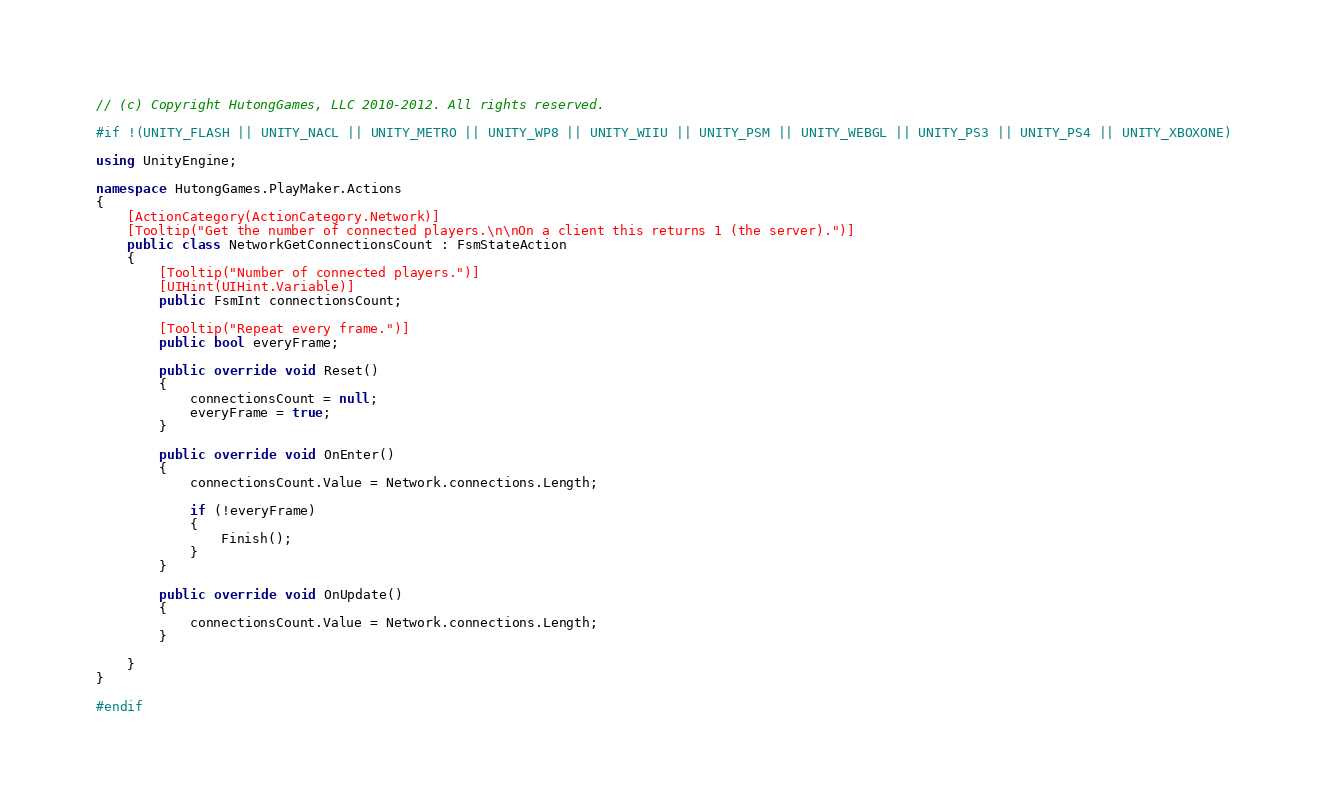<code> <loc_0><loc_0><loc_500><loc_500><_C#_>// (c) Copyright HutongGames, LLC 2010-2012. All rights reserved.

#if !(UNITY_FLASH || UNITY_NACL || UNITY_METRO || UNITY_WP8 || UNITY_WIIU || UNITY_PSM || UNITY_WEBGL || UNITY_PS3 || UNITY_PS4 || UNITY_XBOXONE)

using UnityEngine;

namespace HutongGames.PlayMaker.Actions
{
	[ActionCategory(ActionCategory.Network)]
	[Tooltip("Get the number of connected players.\n\nOn a client this returns 1 (the server).")]
	public class NetworkGetConnectionsCount : FsmStateAction
	{
		[Tooltip("Number of connected players.")]
		[UIHint(UIHint.Variable)]
		public FsmInt connectionsCount;
		
		[Tooltip("Repeat every frame.")]
		public bool everyFrame;

		public override void Reset()
		{
			connectionsCount = null;
			everyFrame = true;
		}

		public override void OnEnter()
		{
			connectionsCount.Value = Network.connections.Length;
			
			if (!everyFrame)
			{
				Finish();
			}
		}

		public override void OnUpdate()
		{
			connectionsCount.Value = Network.connections.Length;
		}

	}
}

#endif</code> 